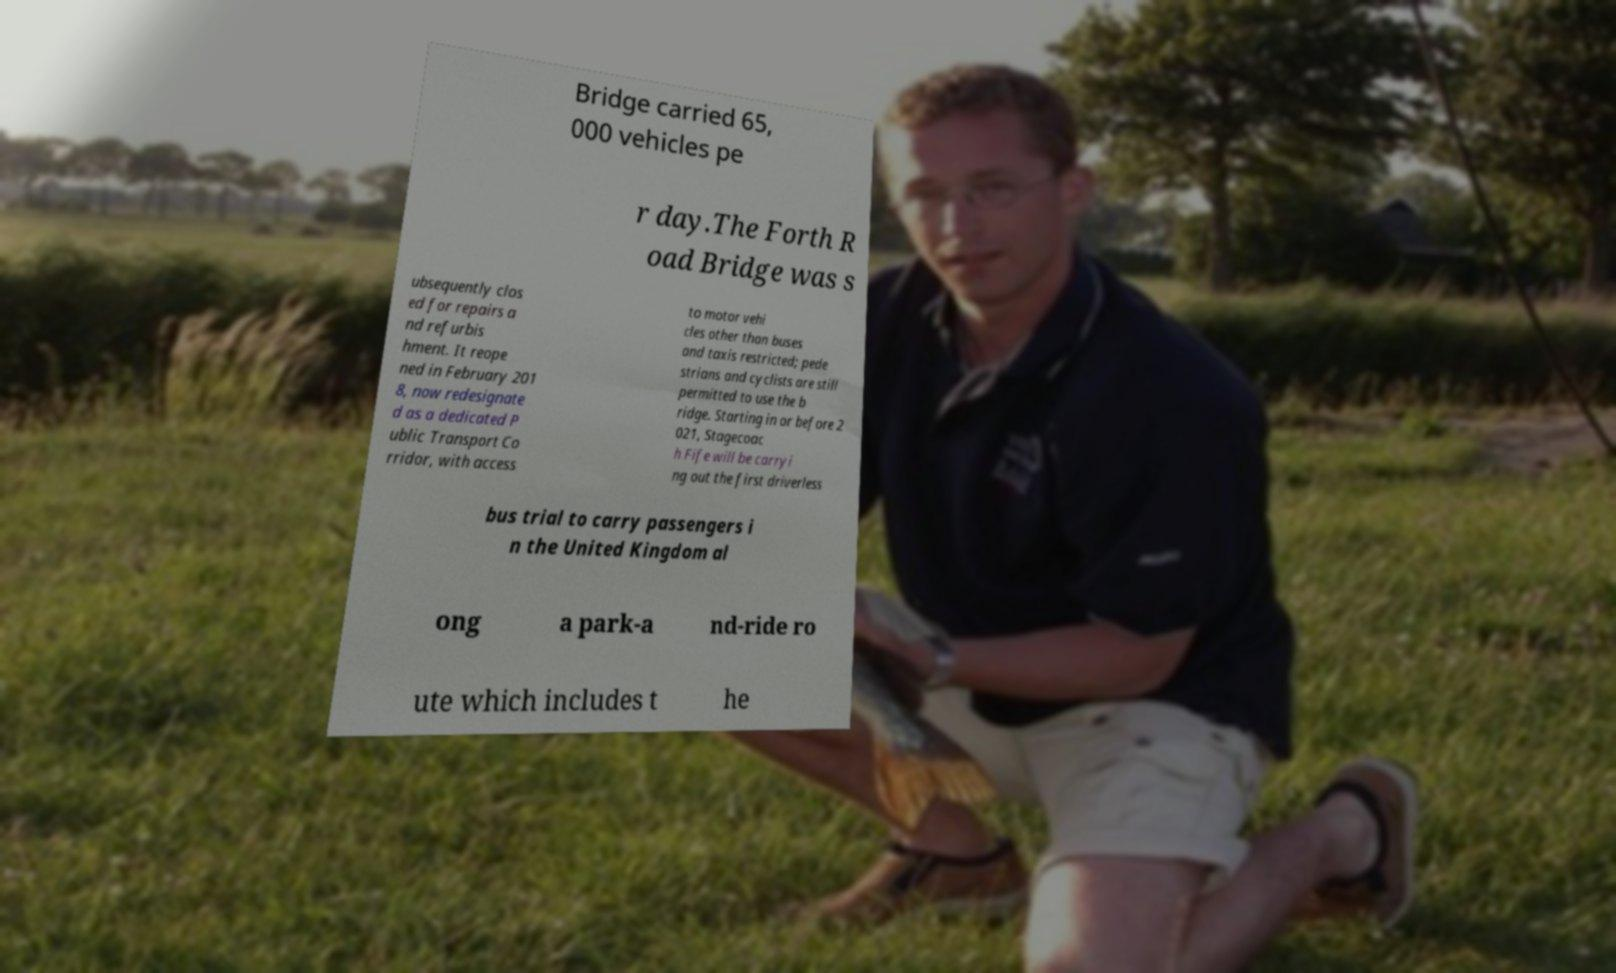Please read and relay the text visible in this image. What does it say? Bridge carried 65, 000 vehicles pe r day.The Forth R oad Bridge was s ubsequently clos ed for repairs a nd refurbis hment. It reope ned in February 201 8, now redesignate d as a dedicated P ublic Transport Co rridor, with access to motor vehi cles other than buses and taxis restricted; pede strians and cyclists are still permitted to use the b ridge. Starting in or before 2 021, Stagecoac h Fife will be carryi ng out the first driverless bus trial to carry passengers i n the United Kingdom al ong a park-a nd-ride ro ute which includes t he 